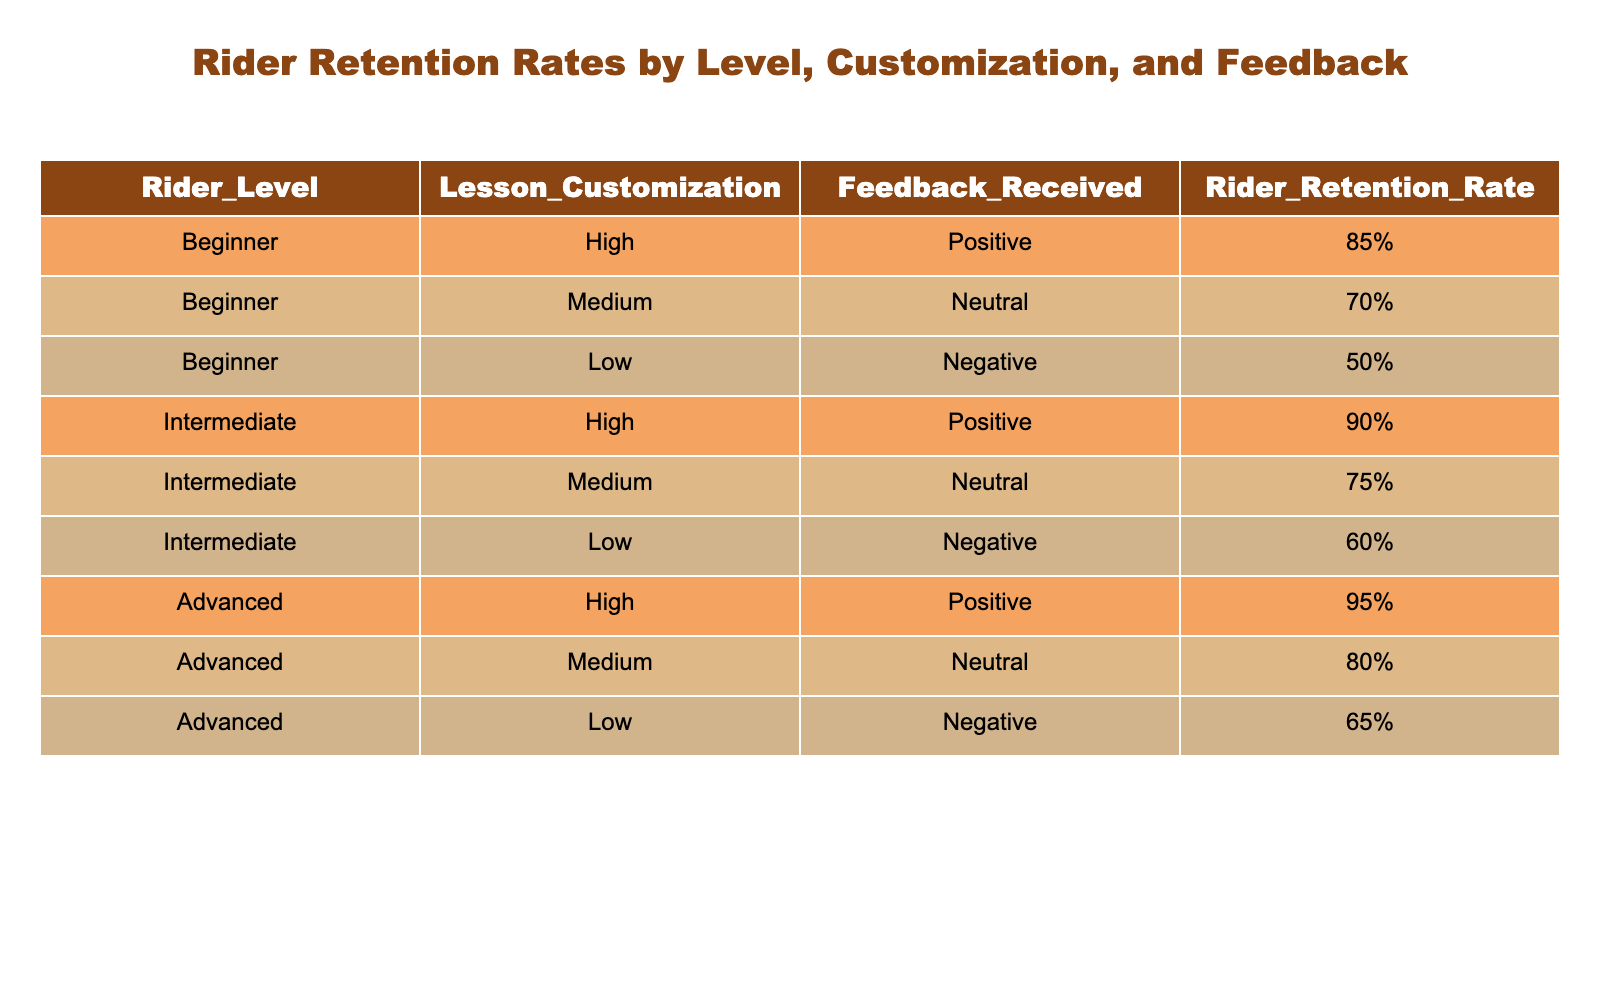What is the rider retention rate for advanced riders with positive feedback? The table states that for advanced riders, with high customization and positive feedback, the retention rate is 95%.
Answer: 95% What was the least retention rate among beginner riders? The table shows that the least retention rate for beginner riders is 50%, which corresponds to low lesson customization and negative feedback.
Answer: 50% Which rider level experienced the highest retention rate overall? The advanced level has the highest retention rate at 95%, followed by intermediate at 90%. Therefore, the highest overall retention rate is for advanced riders.
Answer: Advanced Are there more riders with positive feedback or negative feedback in the data? By counting, there are 4 instances of positive feedback (all levels with high customization) and 3 instances of negative feedback (all levels with low customization). Hence, there are more positive feedback cases.
Answer: Yes Calculate the average retention rate for intermediate riders. The retention rates for intermediate riders are 90%, 75%, and 60%. Summing these gives 90 + 75 + 60 = 225, and dividing by 3 (the number of data points for intermediate) results in an average of 225/3 = 75.
Answer: 75% Does a high lesson customization guarantee positive feedback for all rider levels? The table shows that while higher customization tends to lead to positive feedback, it does not guarantee it. For instance, intermediate and advanced riders both retain high rates with positive feedback, while beginner riders' low retention with negative feedback indicates not all customization yields positive results.
Answer: No What is the difference in retention rates between medium and low customization for intermediate riders? For intermediate riders, the retention rate for medium customization is 75% and for low customization it is 60%. The difference is 75 - 60 = 15.
Answer: 15 What can be inferred about the impact of customization on rider retention rates? The data indicates that higher lesson customization correlates with higher retention rates across all rider levels. For example, all levels with high customization have significantly higher retention rates than those with low customization.
Answer: Higher customization improves retention What is the total percentage of retention rates across all levels for high customization? The retention rates for high customization across all levels are 85% (beginner), 90% (intermediate), and 95% (advanced). Summing these gives 85 + 90 + 95 = 270.
Answer: 270% 